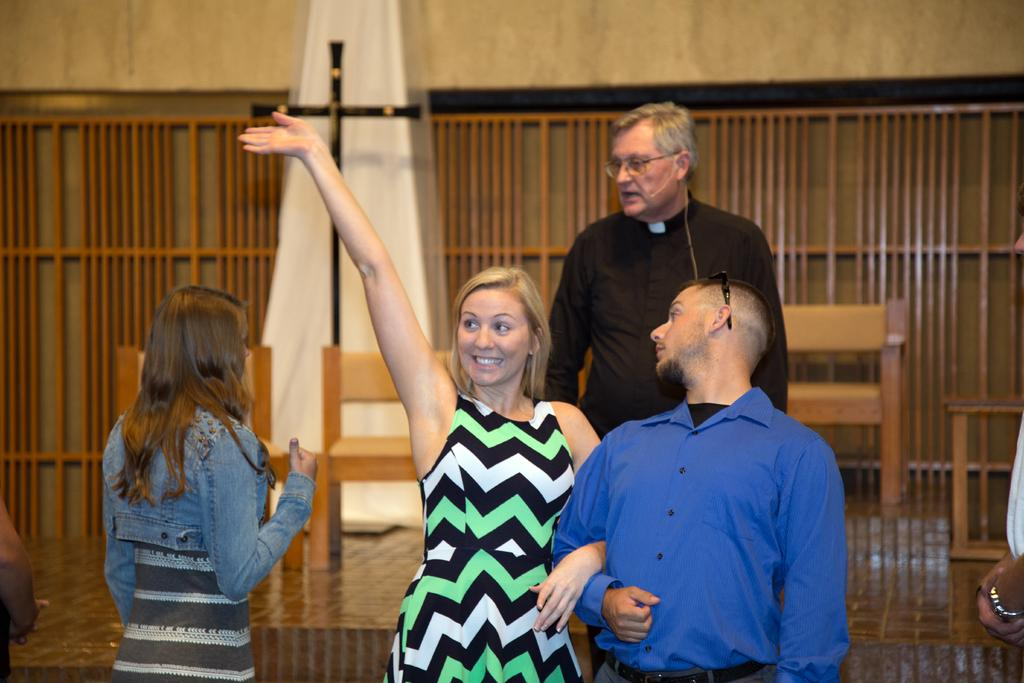What is the main subject of the image? There is a group of people standing in the image. What religious symbol can be seen in the image? There is a cross visible in the image. What type of furniture is present in the image? There are chairs in the image. What material is used for the visible cloth in the image? The cloth visible in the image is made of an unspecified material. What type of structure can be seen in the image? There are wooden poles and a wall in the image. What type of rifle is being used by the monkey in the image? There is no monkey or rifle present in the image. 